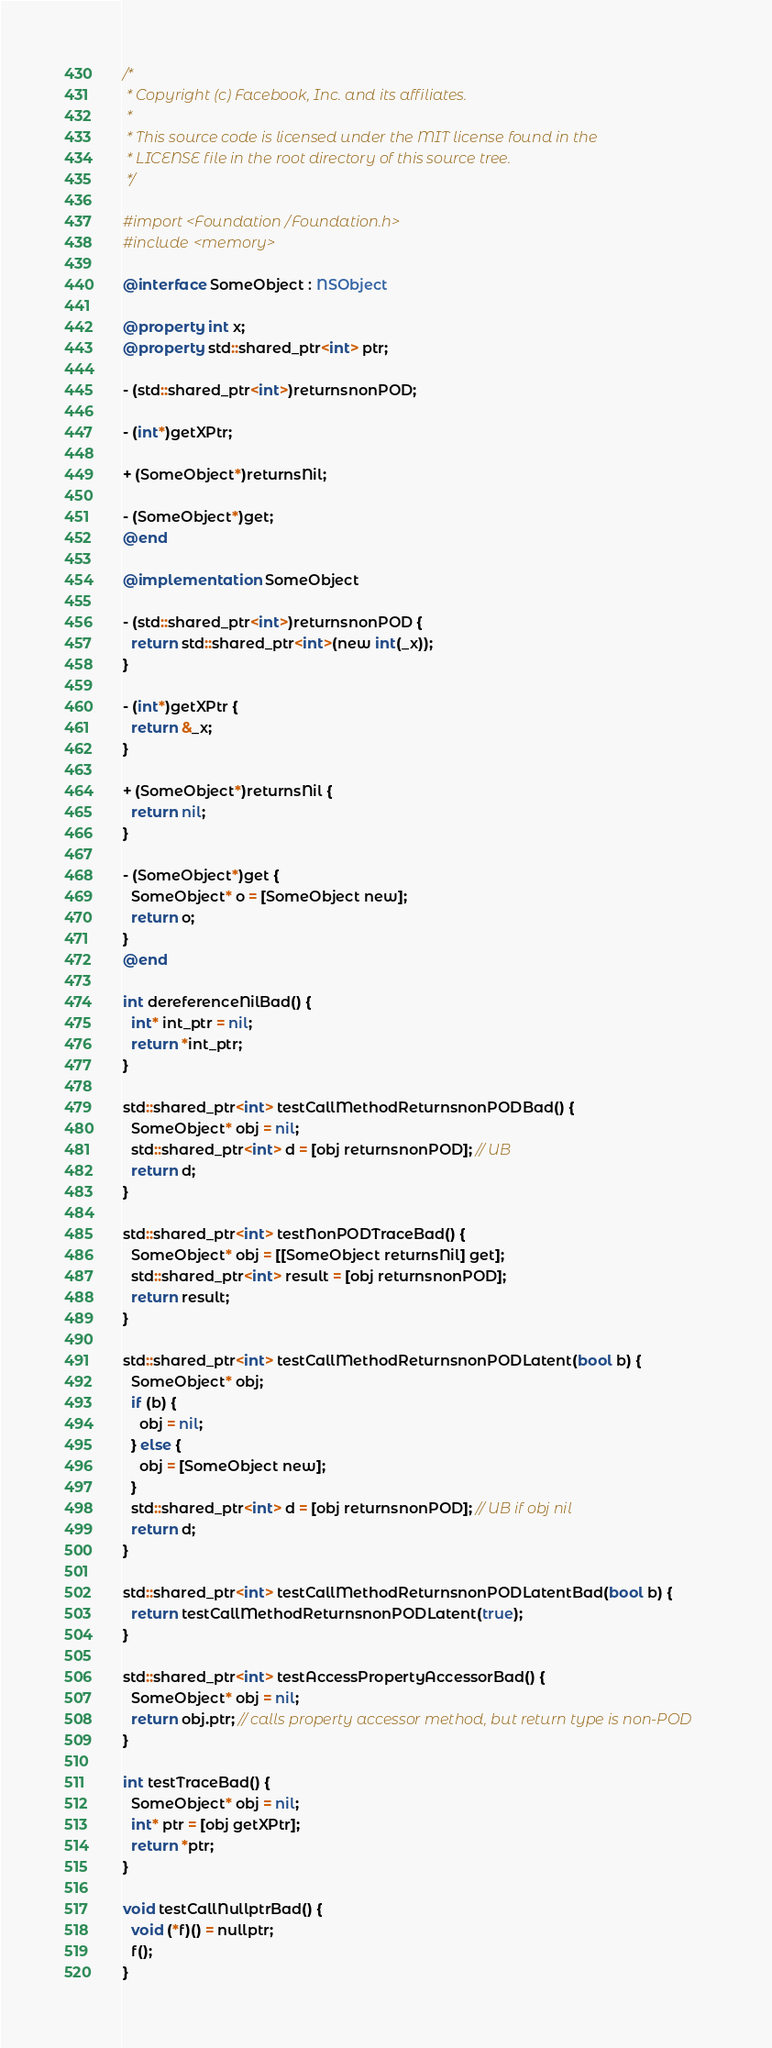<code> <loc_0><loc_0><loc_500><loc_500><_ObjectiveC_>/*
 * Copyright (c) Facebook, Inc. and its affiliates.
 *
 * This source code is licensed under the MIT license found in the
 * LICENSE file in the root directory of this source tree.
 */

#import <Foundation/Foundation.h>
#include <memory>

@interface SomeObject : NSObject

@property int x;
@property std::shared_ptr<int> ptr;

- (std::shared_ptr<int>)returnsnonPOD;

- (int*)getXPtr;

+ (SomeObject*)returnsNil;

- (SomeObject*)get;
@end

@implementation SomeObject

- (std::shared_ptr<int>)returnsnonPOD {
  return std::shared_ptr<int>(new int(_x));
}

- (int*)getXPtr {
  return &_x;
}

+ (SomeObject*)returnsNil {
  return nil;
}

- (SomeObject*)get {
  SomeObject* o = [SomeObject new];
  return o;
}
@end

int dereferenceNilBad() {
  int* int_ptr = nil;
  return *int_ptr;
}

std::shared_ptr<int> testCallMethodReturnsnonPODBad() {
  SomeObject* obj = nil;
  std::shared_ptr<int> d = [obj returnsnonPOD]; // UB
  return d;
}

std::shared_ptr<int> testNonPODTraceBad() {
  SomeObject* obj = [[SomeObject returnsNil] get];
  std::shared_ptr<int> result = [obj returnsnonPOD];
  return result;
}

std::shared_ptr<int> testCallMethodReturnsnonPODLatent(bool b) {
  SomeObject* obj;
  if (b) {
    obj = nil;
  } else {
    obj = [SomeObject new];
  }
  std::shared_ptr<int> d = [obj returnsnonPOD]; // UB if obj nil
  return d;
}

std::shared_ptr<int> testCallMethodReturnsnonPODLatentBad(bool b) {
  return testCallMethodReturnsnonPODLatent(true);
}

std::shared_ptr<int> testAccessPropertyAccessorBad() {
  SomeObject* obj = nil;
  return obj.ptr; // calls property accessor method, but return type is non-POD
}

int testTraceBad() {
  SomeObject* obj = nil;
  int* ptr = [obj getXPtr];
  return *ptr;
}

void testCallNullptrBad() {
  void (*f)() = nullptr;
  f();
}
</code> 